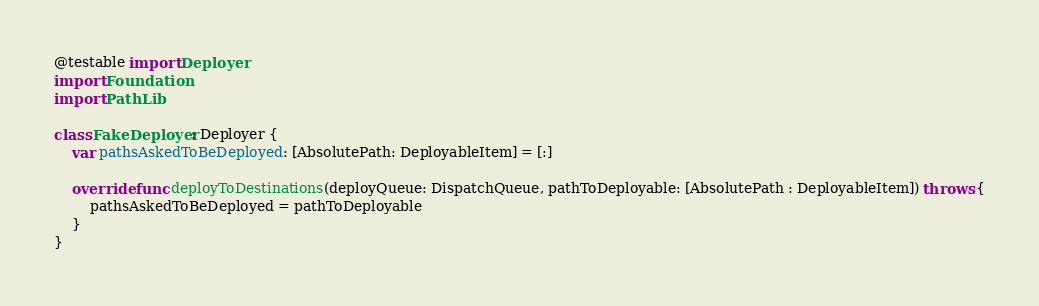Convert code to text. <code><loc_0><loc_0><loc_500><loc_500><_Swift_>@testable import Deployer
import Foundation
import PathLib

class FakeDeployer: Deployer {
    var pathsAskedToBeDeployed: [AbsolutePath: DeployableItem] = [:]
    
    override func deployToDestinations(deployQueue: DispatchQueue, pathToDeployable: [AbsolutePath : DeployableItem]) throws {
        pathsAskedToBeDeployed = pathToDeployable
    }
}
</code> 